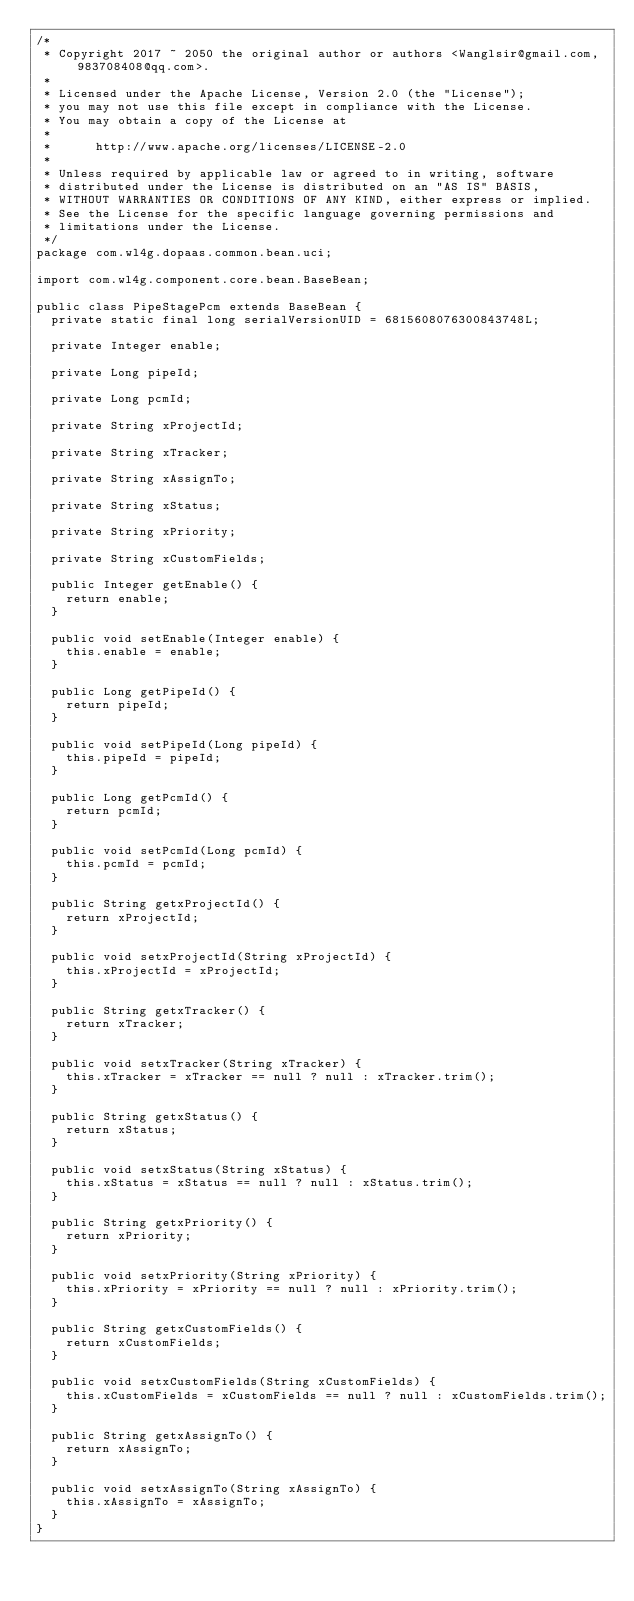Convert code to text. <code><loc_0><loc_0><loc_500><loc_500><_Java_>/*
 * Copyright 2017 ~ 2050 the original author or authors <Wanglsir@gmail.com, 983708408@qq.com>.
 *
 * Licensed under the Apache License, Version 2.0 (the "License");
 * you may not use this file except in compliance with the License.
 * You may obtain a copy of the License at
 *
 *      http://www.apache.org/licenses/LICENSE-2.0
 *
 * Unless required by applicable law or agreed to in writing, software
 * distributed under the License is distributed on an "AS IS" BASIS,
 * WITHOUT WARRANTIES OR CONDITIONS OF ANY KIND, either express or implied.
 * See the License for the specific language governing permissions and
 * limitations under the License.
 */
package com.wl4g.dopaas.common.bean.uci;

import com.wl4g.component.core.bean.BaseBean;

public class PipeStagePcm extends BaseBean {
	private static final long serialVersionUID = 6815608076300843748L;

	private Integer enable;

	private Long pipeId;

	private Long pcmId;

	private String xProjectId;

	private String xTracker;

	private String xAssignTo;

	private String xStatus;

	private String xPriority;

	private String xCustomFields;

	public Integer getEnable() {
		return enable;
	}

	public void setEnable(Integer enable) {
		this.enable = enable;
	}

	public Long getPipeId() {
		return pipeId;
	}

	public void setPipeId(Long pipeId) {
		this.pipeId = pipeId;
	}

	public Long getPcmId() {
		return pcmId;
	}

	public void setPcmId(Long pcmId) {
		this.pcmId = pcmId;
	}

	public String getxProjectId() {
		return xProjectId;
	}

	public void setxProjectId(String xProjectId) {
		this.xProjectId = xProjectId;
	}

	public String getxTracker() {
		return xTracker;
	}

	public void setxTracker(String xTracker) {
		this.xTracker = xTracker == null ? null : xTracker.trim();
	}

	public String getxStatus() {
		return xStatus;
	}

	public void setxStatus(String xStatus) {
		this.xStatus = xStatus == null ? null : xStatus.trim();
	}

	public String getxPriority() {
		return xPriority;
	}

	public void setxPriority(String xPriority) {
		this.xPriority = xPriority == null ? null : xPriority.trim();
	}

	public String getxCustomFields() {
		return xCustomFields;
	}

	public void setxCustomFields(String xCustomFields) {
		this.xCustomFields = xCustomFields == null ? null : xCustomFields.trim();
	}

	public String getxAssignTo() {
		return xAssignTo;
	}

	public void setxAssignTo(String xAssignTo) {
		this.xAssignTo = xAssignTo;
	}
}</code> 